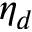<formula> <loc_0><loc_0><loc_500><loc_500>\eta _ { d }</formula> 